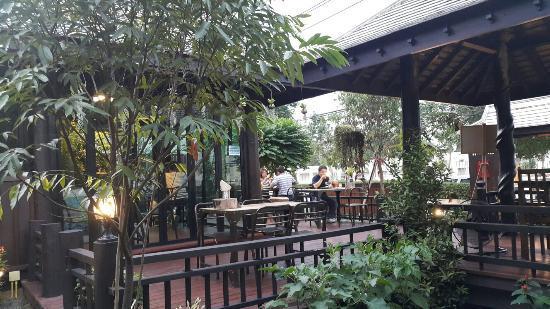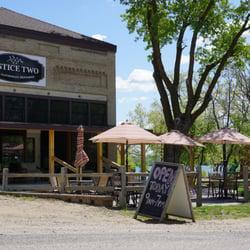The first image is the image on the left, the second image is the image on the right. Evaluate the accuracy of this statement regarding the images: "There are at most 2 umbrellas in the image on the right.". Is it true? Answer yes or no. No. The first image is the image on the left, the second image is the image on the right. Given the left and right images, does the statement "In one image, an outdoor seating area in front of a building includes at least two solid-colored patio umbrellas." hold true? Answer yes or no. Yes. 